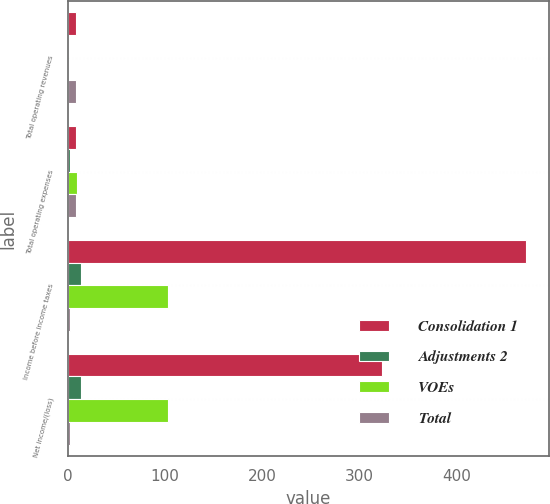Convert chart to OTSL. <chart><loc_0><loc_0><loc_500><loc_500><stacked_bar_chart><ecel><fcel>Total operating revenues<fcel>Total operating expenses<fcel>Income before income taxes<fcel>Net income/(loss)<nl><fcel>Consolidation 1<fcel>8.75<fcel>8.75<fcel>471.4<fcel>323.2<nl><fcel>Adjustments 2<fcel>0.3<fcel>1.8<fcel>13.1<fcel>13.1<nl><fcel>VOEs<fcel>1.6<fcel>9.6<fcel>103.3<fcel>103.3<nl><fcel>Total<fcel>7.9<fcel>7.9<fcel>2.5<fcel>2.5<nl></chart> 